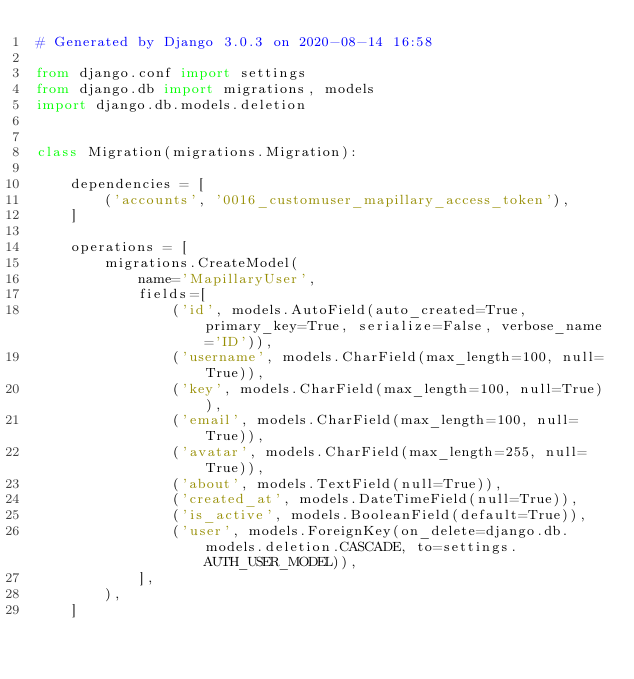<code> <loc_0><loc_0><loc_500><loc_500><_Python_># Generated by Django 3.0.3 on 2020-08-14 16:58

from django.conf import settings
from django.db import migrations, models
import django.db.models.deletion


class Migration(migrations.Migration):

    dependencies = [
        ('accounts', '0016_customuser_mapillary_access_token'),
    ]

    operations = [
        migrations.CreateModel(
            name='MapillaryUser',
            fields=[
                ('id', models.AutoField(auto_created=True, primary_key=True, serialize=False, verbose_name='ID')),
                ('username', models.CharField(max_length=100, null=True)),
                ('key', models.CharField(max_length=100, null=True)),
                ('email', models.CharField(max_length=100, null=True)),
                ('avatar', models.CharField(max_length=255, null=True)),
                ('about', models.TextField(null=True)),
                ('created_at', models.DateTimeField(null=True)),
                ('is_active', models.BooleanField(default=True)),
                ('user', models.ForeignKey(on_delete=django.db.models.deletion.CASCADE, to=settings.AUTH_USER_MODEL)),
            ],
        ),
    ]
</code> 